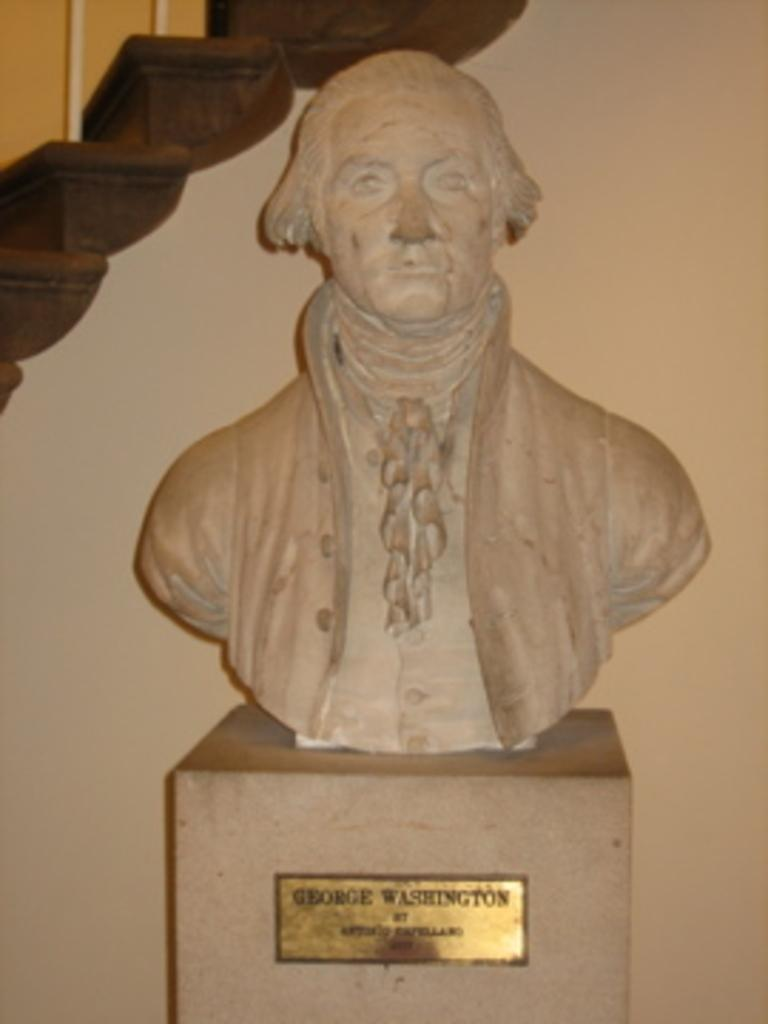What is the main subject of the image? There is a sculpture in the image. How is the sculpture displayed? The sculpture is on a pedestal. What can be seen in the background of the image? There are stairs and a wall in the background of the image. How many fish are swimming around the sculpture in the image? There are no fish present in the image; it features a sculpture on a pedestal with stairs and a wall in the background. 